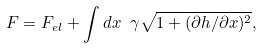<formula> <loc_0><loc_0><loc_500><loc_500>F = F _ { e l } + \int d x \ \gamma \sqrt { 1 + ( \partial h / \partial x ) ^ { 2 } } ,</formula> 